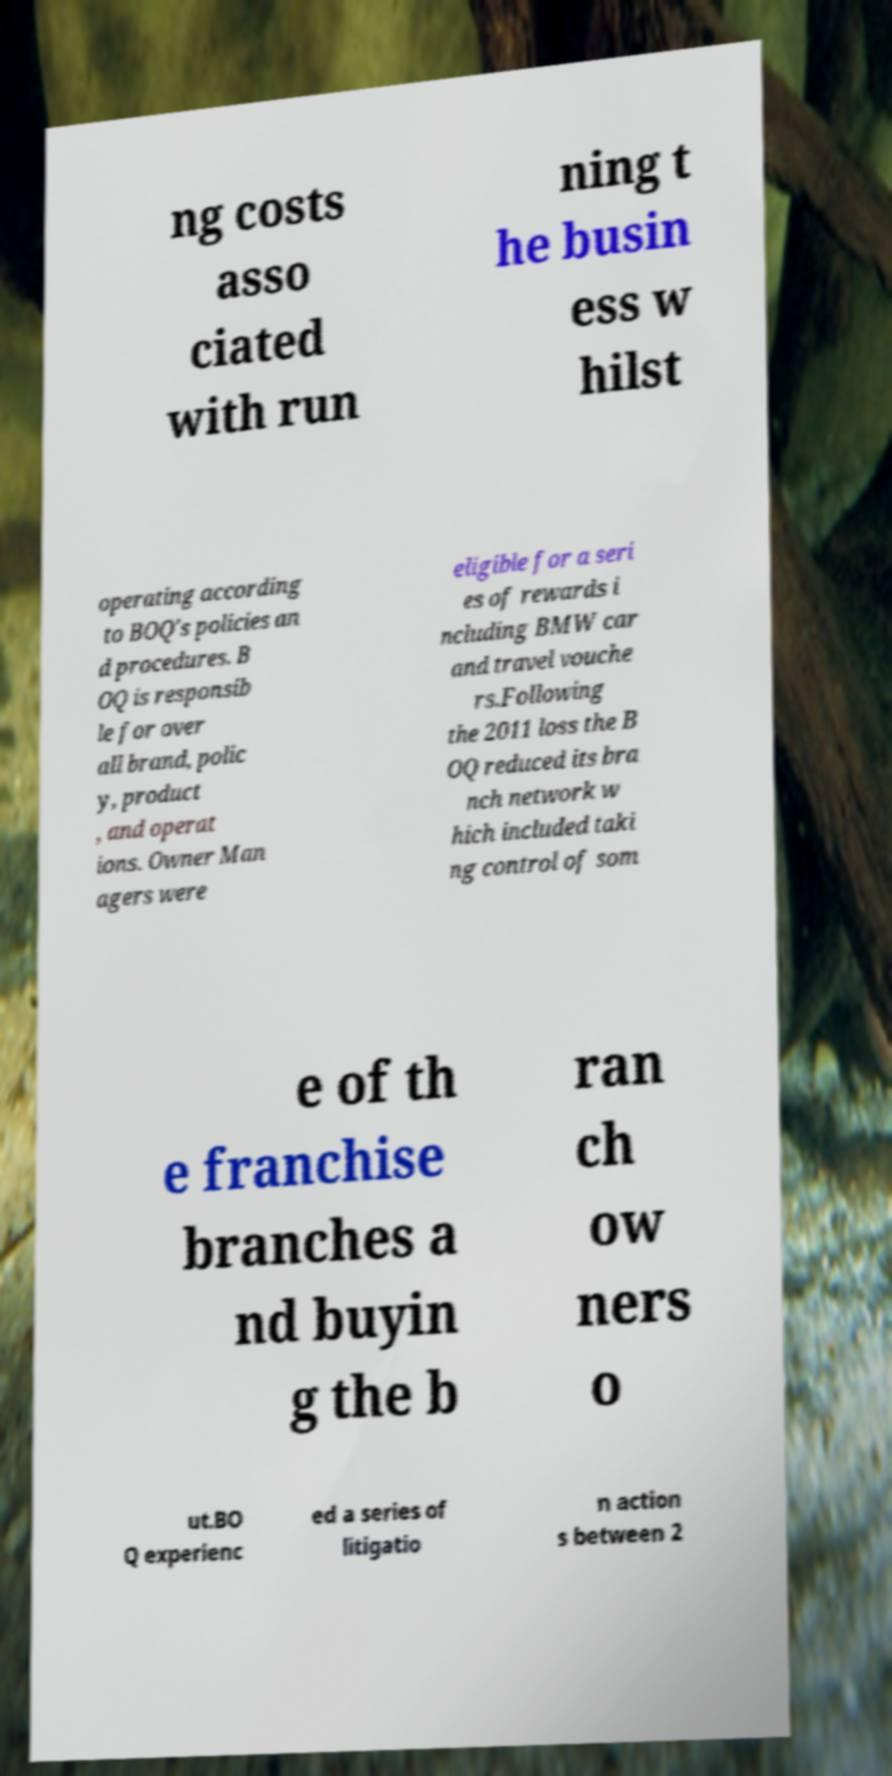What messages or text are displayed in this image? I need them in a readable, typed format. ng costs asso ciated with run ning t he busin ess w hilst operating according to BOQ's policies an d procedures. B OQ is responsib le for over all brand, polic y, product , and operat ions. Owner Man agers were eligible for a seri es of rewards i ncluding BMW car and travel vouche rs.Following the 2011 loss the B OQ reduced its bra nch network w hich included taki ng control of som e of th e franchise branches a nd buyin g the b ran ch ow ners o ut.BO Q experienc ed a series of litigatio n action s between 2 